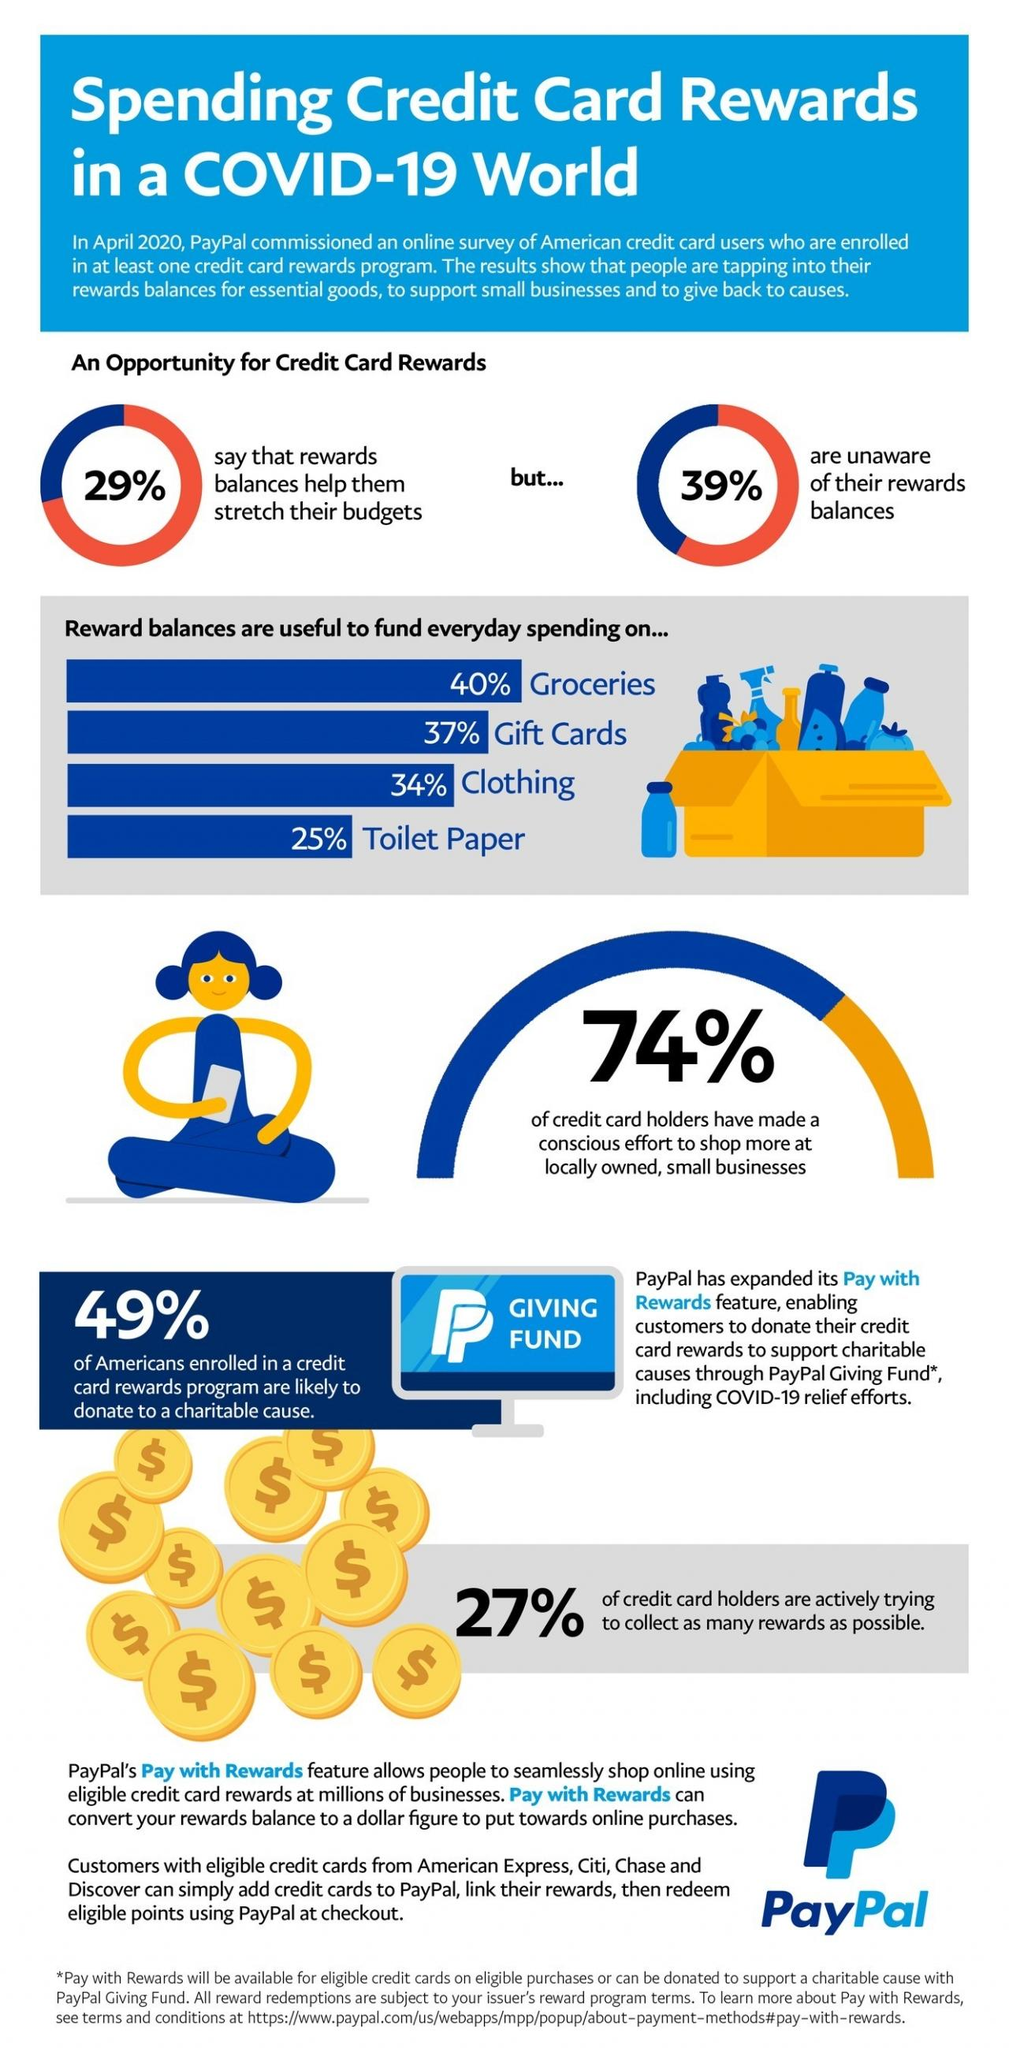List a handful of essential elements in this visual. According to a survey conducted by PayPal in April 2020, 61% of American credit card holders are aware of their reward balances. According to a survey conducted by PayPal in April 2020, 40% of credit card reward balances were reportedly spent on groceries. According to the PayPal survey conducted in April 2020, 34% of credit card reward balances were spent on clothing. According to a survey conducted by PayPal in April 2020, 73% of American credit card holders are not actively trying to collect as many rewards as possible. According to a survey conducted by PayPal in April 2020, 37% of credit card reward balances were spent on gift cards. 